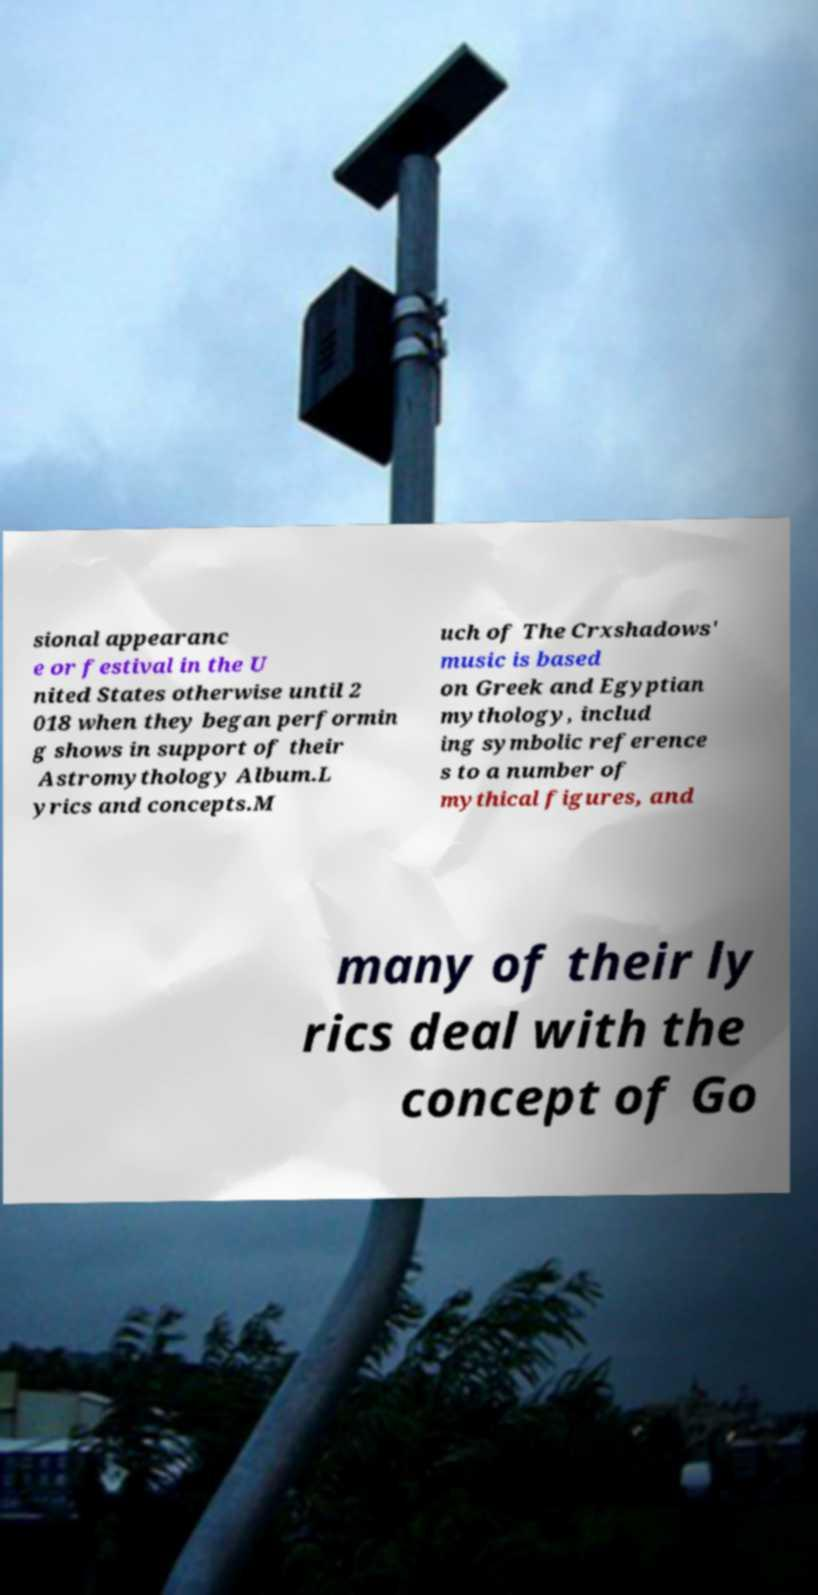For documentation purposes, I need the text within this image transcribed. Could you provide that? sional appearanc e or festival in the U nited States otherwise until 2 018 when they began performin g shows in support of their Astromythology Album.L yrics and concepts.M uch of The Crxshadows' music is based on Greek and Egyptian mythology, includ ing symbolic reference s to a number of mythical figures, and many of their ly rics deal with the concept of Go 